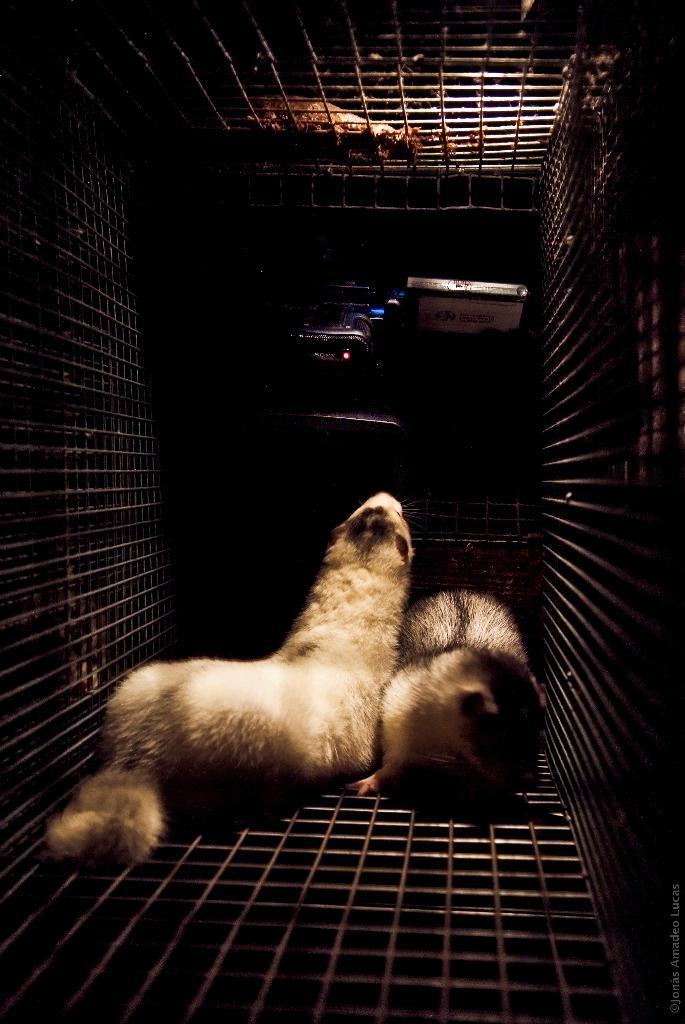How would you summarize this image in a sentence or two? In this image there are two animals in a cage, and in the background there are objects. 